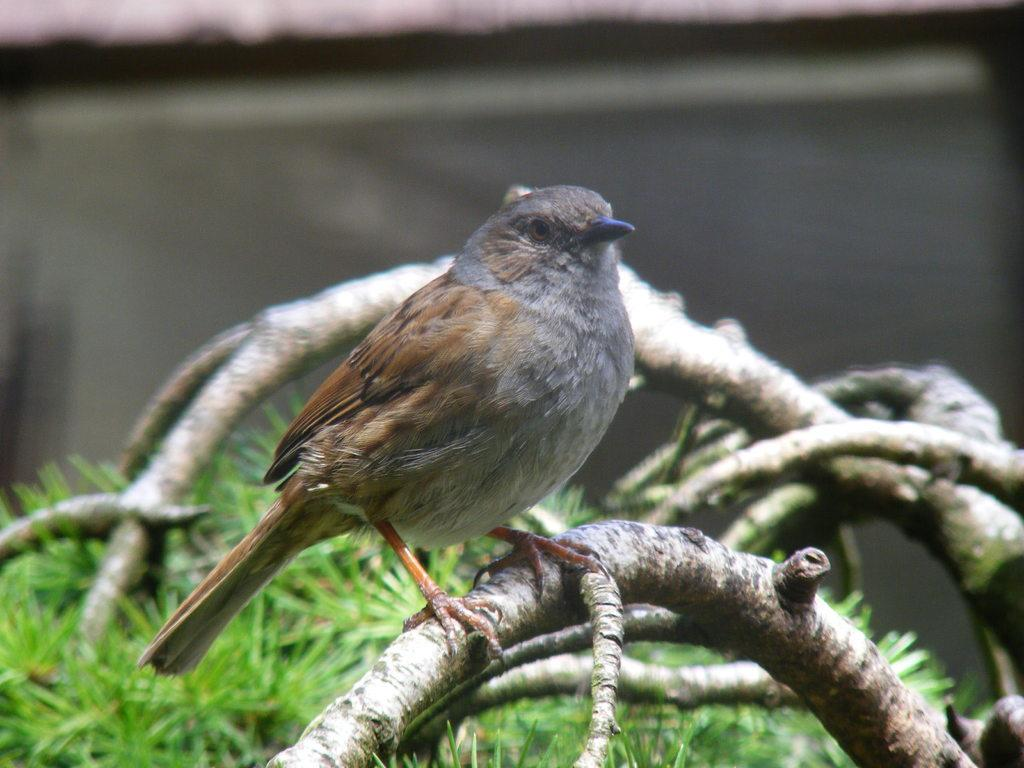What type of animal can be seen in the image? There is a bird in the image. Where is the bird located? The bird is on a tree branch. What type of vegetation is visible in the background of the image? There is grass visible in the background of the image. How would you describe the background of the image? The background appears blurry. What type of polish is the bird using on its beak in the image? There is no polish present in the image, and the bird's beak does not appear to be polished. 